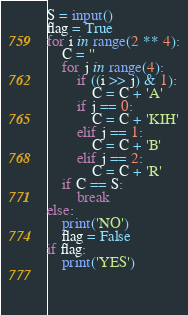<code> <loc_0><loc_0><loc_500><loc_500><_Python_>S = input()
flag = True
for i in range(2 ** 4):
    C = ''
    for j in range(4):
        if ((i >> j) & 1):
            C = C + 'A'
        if j == 0:
            C = C + 'KIH'
        elif j == 1:
            C = C + 'B'
        elif j == 2:
            C = C + 'R'
    if C == S:
        break
else:
    print('NO')
    flag = False
if flag:
    print('YES')
    

    </code> 